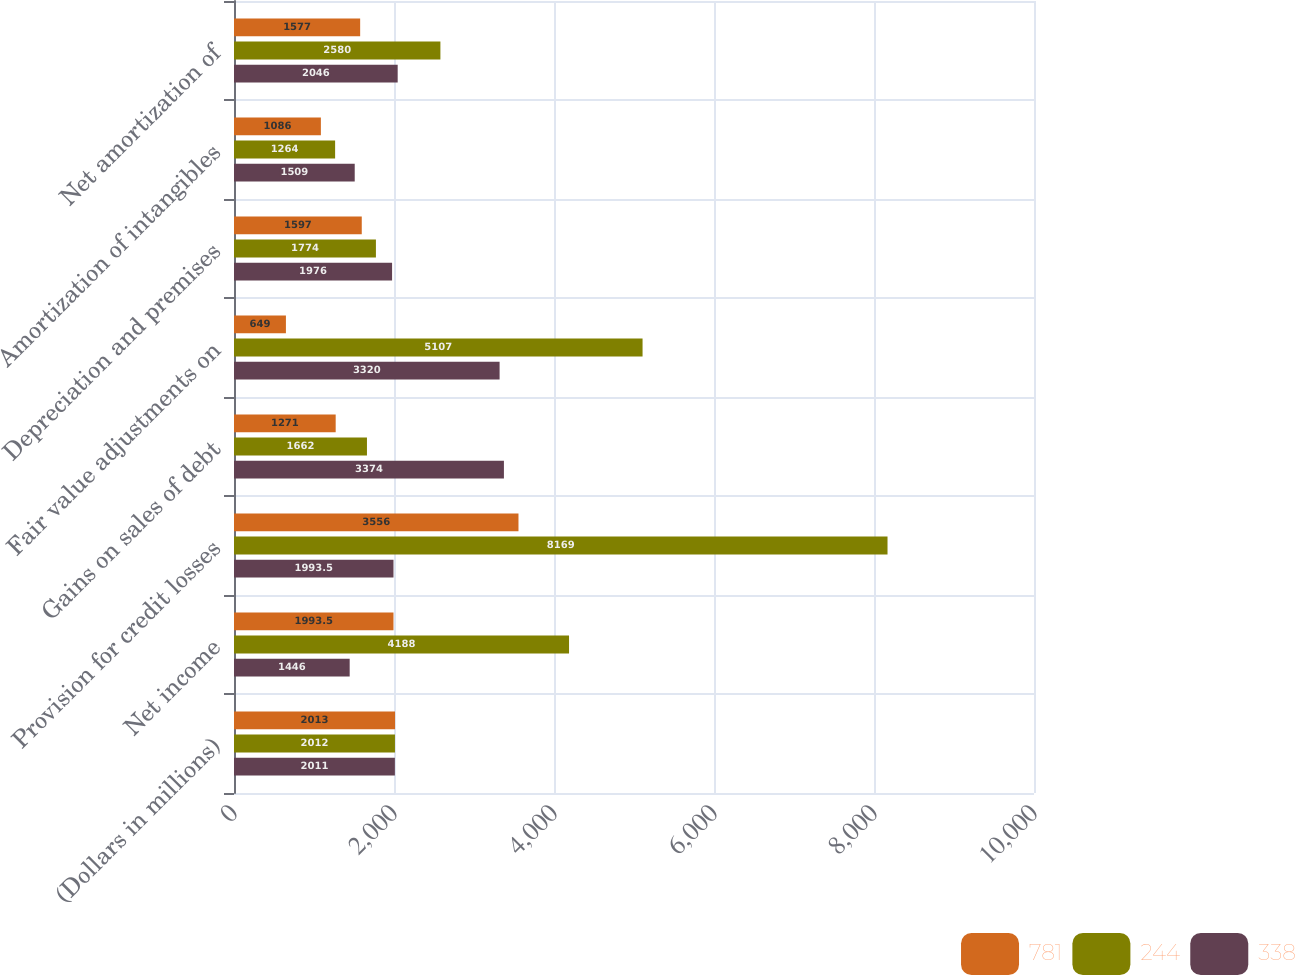<chart> <loc_0><loc_0><loc_500><loc_500><stacked_bar_chart><ecel><fcel>(Dollars in millions)<fcel>Net income<fcel>Provision for credit losses<fcel>Gains on sales of debt<fcel>Fair value adjustments on<fcel>Depreciation and premises<fcel>Amortization of intangibles<fcel>Net amortization of<nl><fcel>781<fcel>2013<fcel>1993.5<fcel>3556<fcel>1271<fcel>649<fcel>1597<fcel>1086<fcel>1577<nl><fcel>244<fcel>2012<fcel>4188<fcel>8169<fcel>1662<fcel>5107<fcel>1774<fcel>1264<fcel>2580<nl><fcel>338<fcel>2011<fcel>1446<fcel>1993.5<fcel>3374<fcel>3320<fcel>1976<fcel>1509<fcel>2046<nl></chart> 